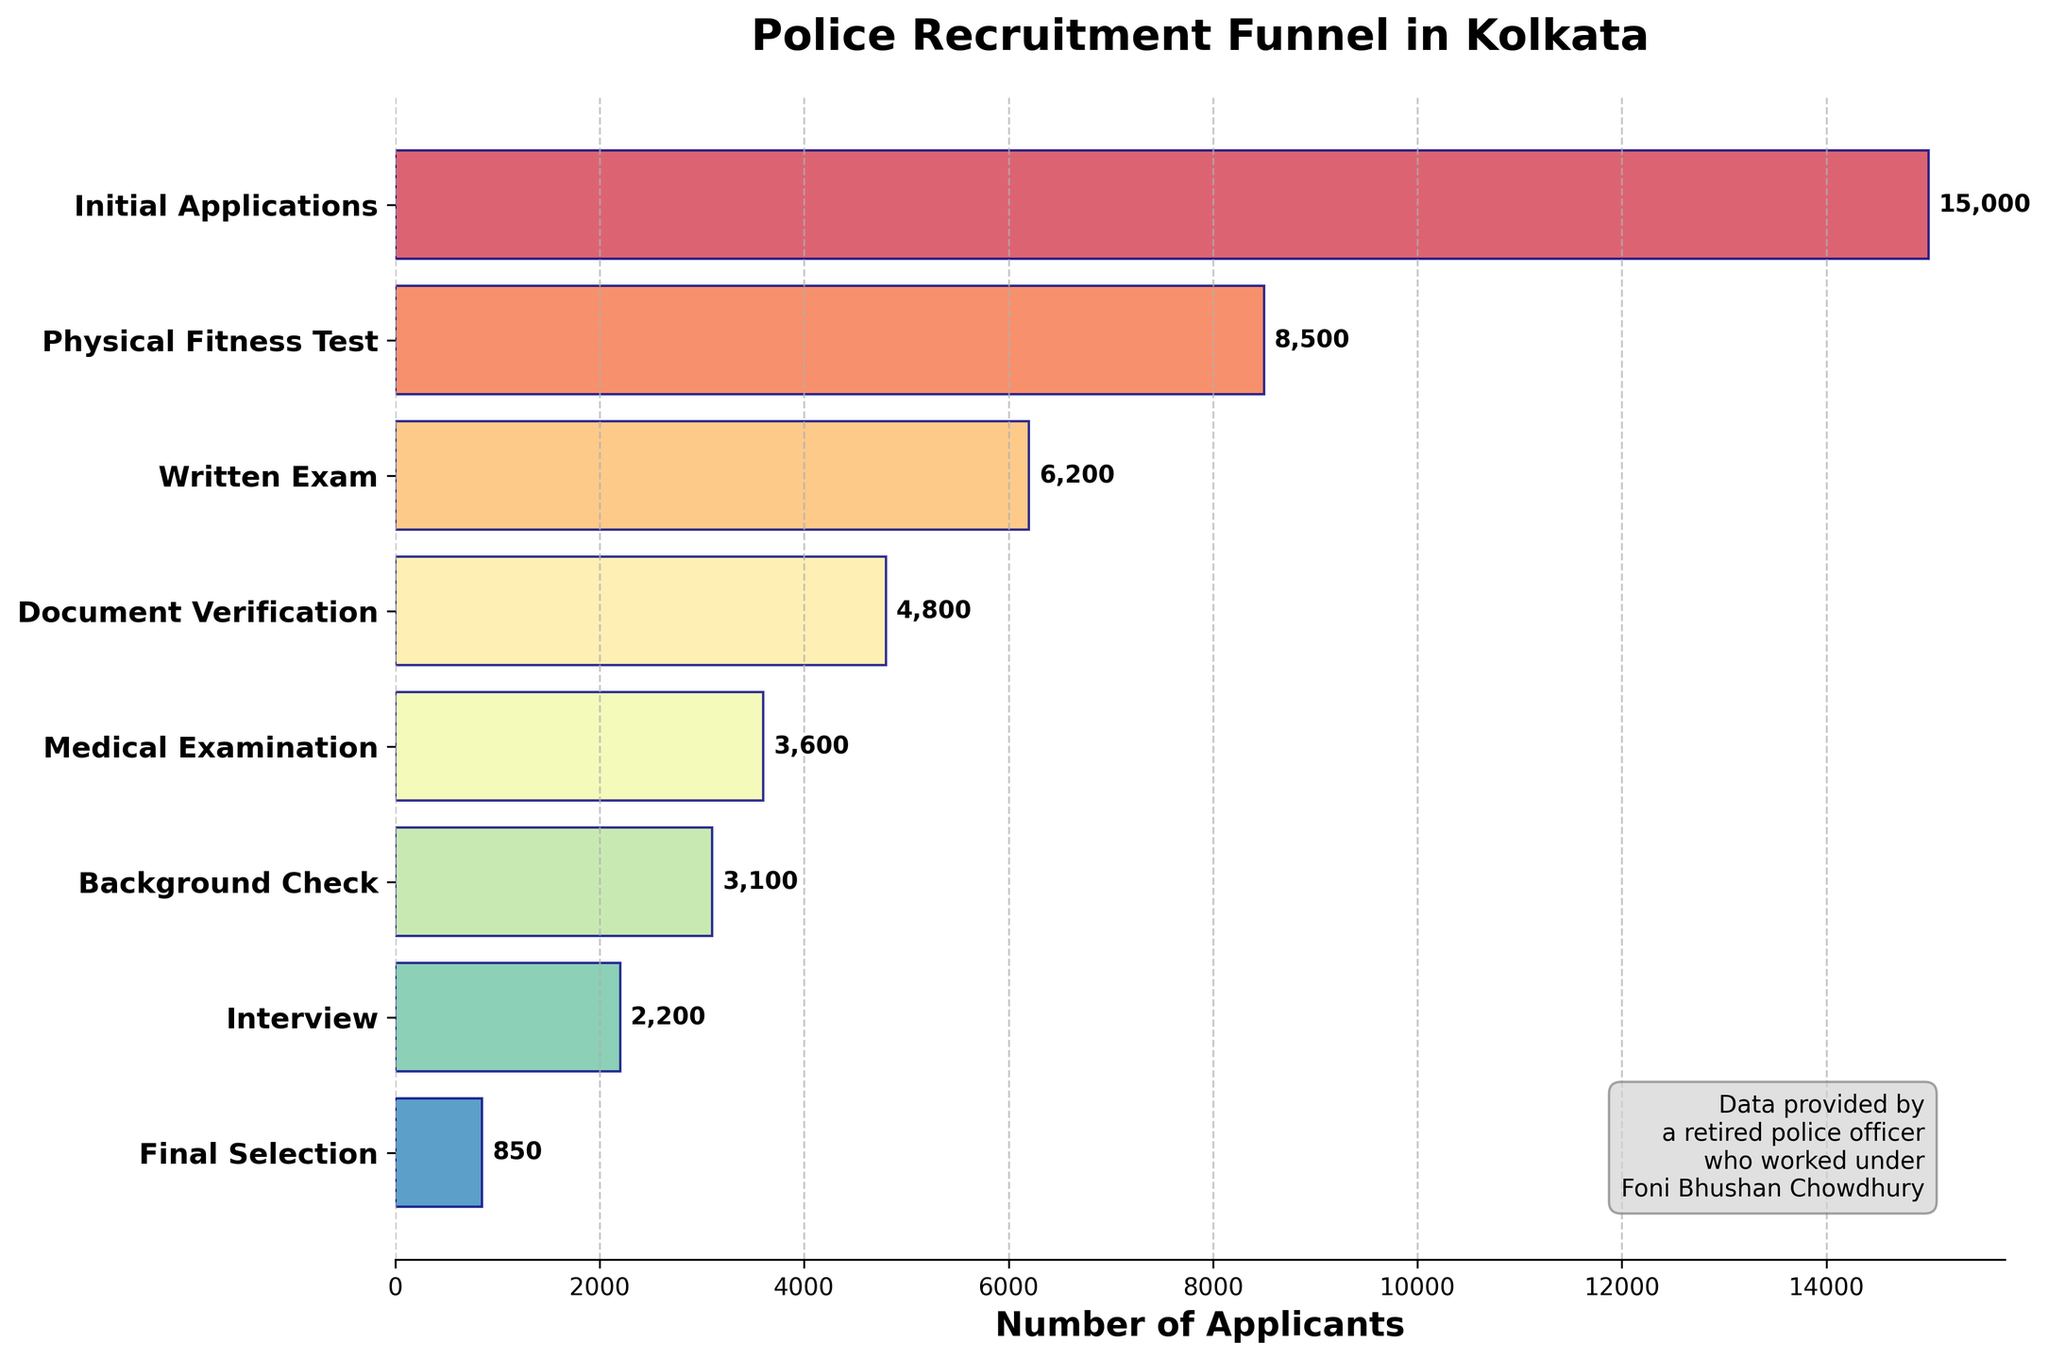What's the title of the funnel chart? The title of the funnel chart is displayed prominently at the top in bold. It reads, "Police Recruitment Funnel in Kolkata".
Answer: "Police Recruitment Funnel in Kolkata" How many stages are depicted in the funnel chart? By counting the number of horizontal bars (each representing a stage) on the y-axis, we can see there are 8 stages in total.
Answer: 8 What is the difference in the number of applicants between the "Initial Applications" and "Final Selection" stages? The number of applicants in the "Initial Applications" stage is 15,000, and in the "Final Selection" stage is 850. The difference is calculated as 15,000 - 850.
Answer: 14,150 How many applicants are lost between the "Physical Fitness Test" and the "Written Exam"? The number of applicants in the "Physical Fitness Test" is 8,500, and in the "Written Exam" is 6,200. The difference is 8,500 - 6,200.
Answer: 2,300 Which stage has the highest number of applicants, and what is this number? The stage with the highest number of applicants can be identified by looking at the longest horizontal bar on the chart. This stage is "Initial Applications" with 15,000 applicants.
Answer: "Initial Applications", 15,000 Which stage has the lowest number of applicants, and what is this number? The stage with the lowest number of applicants can be identified by looking at the shortest horizontal bar on the chart. This stage is "Final Selection" with 850 applicants.
Answer: "Final Selection", 850 By what percentage did the applicants decrease from the "Initial Applications" stage to the "Physical Fitness Test" stage? The number of applicants in the "Initial Applications" stage is 15,000, and in the "Physical Fitness Test" stage is 8,500. The percentage decrease is calculated as ((15,000 - 8,500) / 15,000) * 100.
Answer: 43.33% What proportion of the applicants who went through the "Background Check" made it to the "Final Selection"? The number of applicants in the "Background Check" is 3,100, and in the "Final Selection" is 850. The proportion is calculated as 850 / 3,100.
Answer: 27.42% Between which two consecutive stages is the greatest drop in the number of applicants observed? By comparing the differences in applicant numbers between each pair of consecutive stages, the greatest drop is between "Interview" (2,200) and "Final Selection" (850). The difference is 1,350.
Answer: "Interview" to "Final Selection" On average, how many applicants pass from one stage to the next, excluding the initial and final stages? The number of applicants passing from one stage to the next can be averaged by summing the applicants at each intermediate stage and dividing by the number of these stages. The intermediate stages are "Physical Fitness Test", "Written Exam", "Document Verification", "Medical Examination", "Background Check", and "Interview", totaling 6 stages. Sum = 8,500 + 6,200 + 4,800 + 3,600 + 3,100 + 2,200 = 28,400. Average = 28,400 / 6.
Answer: 4,733 